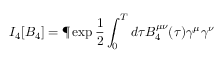<formula> <loc_0><loc_0><loc_500><loc_500>I _ { 4 } [ B _ { 4 } ] = \P \exp \frac { 1 } { 2 } \int _ { 0 } ^ { T } d \tau B _ { 4 } ^ { \mu \nu } ( \tau ) \gamma ^ { \mu } \gamma ^ { \nu }</formula> 